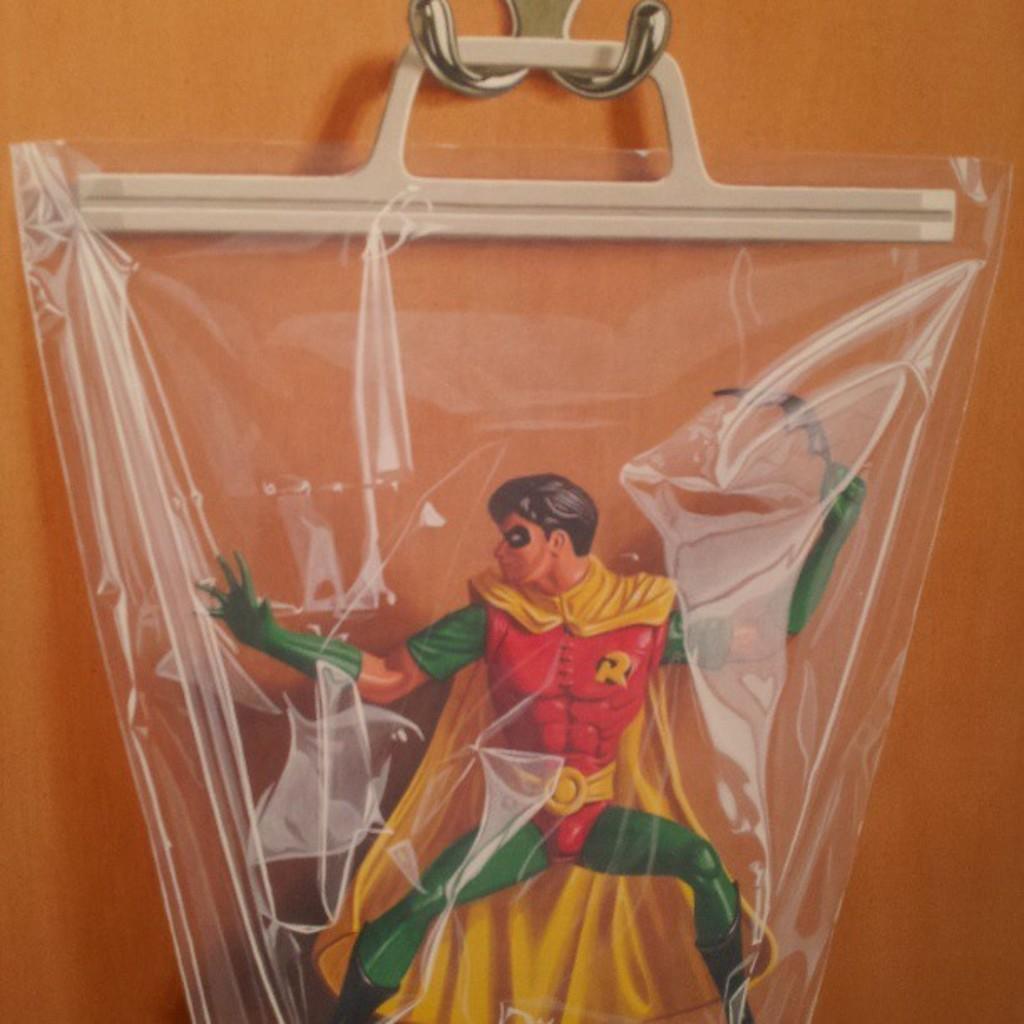Can you describe this image briefly? In this image there is a wall to that wall there is a toy hanged. 